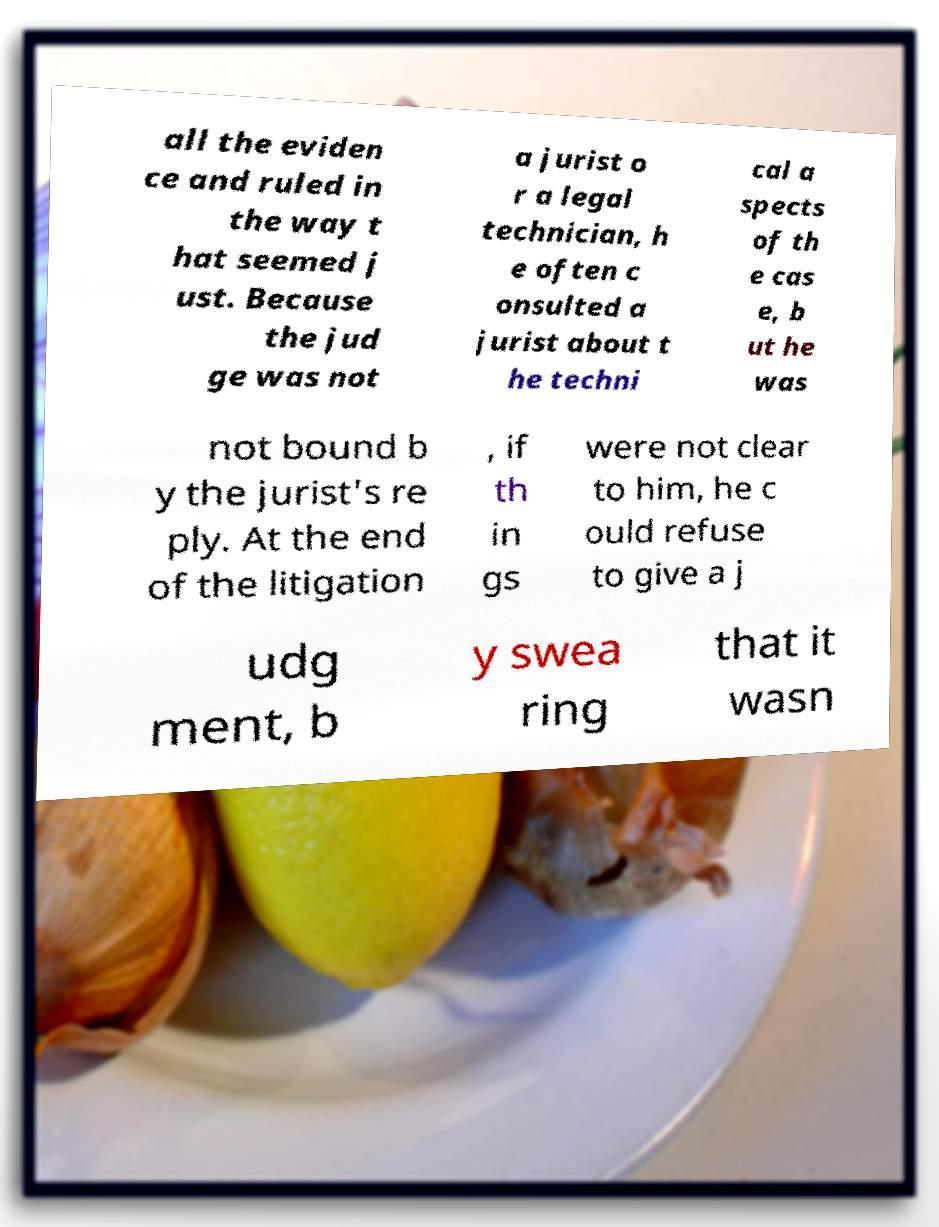Could you assist in decoding the text presented in this image and type it out clearly? all the eviden ce and ruled in the way t hat seemed j ust. Because the jud ge was not a jurist o r a legal technician, h e often c onsulted a jurist about t he techni cal a spects of th e cas e, b ut he was not bound b y the jurist's re ply. At the end of the litigation , if th in gs were not clear to him, he c ould refuse to give a j udg ment, b y swea ring that it wasn 